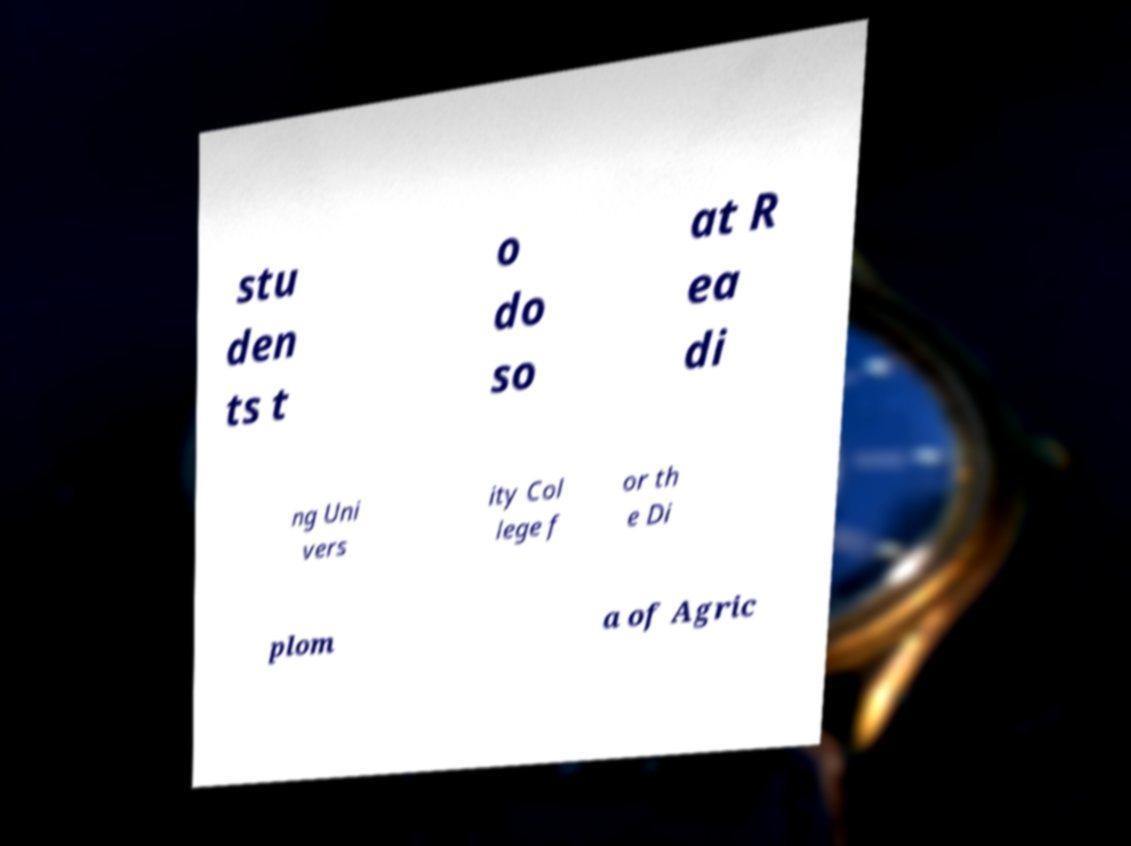Could you assist in decoding the text presented in this image and type it out clearly? stu den ts t o do so at R ea di ng Uni vers ity Col lege f or th e Di plom a of Agric 